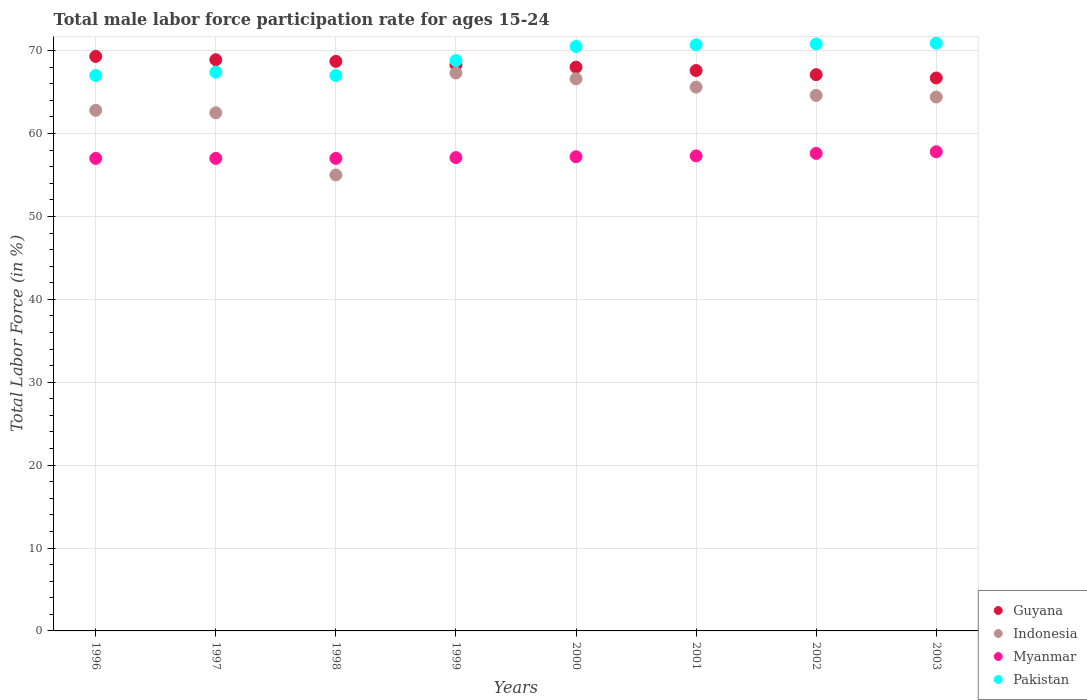How many different coloured dotlines are there?
Offer a very short reply. 4. What is the male labor force participation rate in Pakistan in 1998?
Give a very brief answer. 67. Across all years, what is the maximum male labor force participation rate in Myanmar?
Your answer should be very brief. 57.8. Across all years, what is the minimum male labor force participation rate in Pakistan?
Keep it short and to the point. 67. What is the total male labor force participation rate in Guyana in the graph?
Offer a very short reply. 544.6. What is the difference between the male labor force participation rate in Indonesia in 1998 and that in 1999?
Keep it short and to the point. -12.3. What is the average male labor force participation rate in Pakistan per year?
Ensure brevity in your answer.  69.14. In the year 2002, what is the difference between the male labor force participation rate in Pakistan and male labor force participation rate in Guyana?
Provide a succinct answer. 3.7. What is the ratio of the male labor force participation rate in Pakistan in 2000 to that in 2002?
Provide a short and direct response. 1. Is the difference between the male labor force participation rate in Pakistan in 2000 and 2003 greater than the difference between the male labor force participation rate in Guyana in 2000 and 2003?
Offer a very short reply. No. What is the difference between the highest and the second highest male labor force participation rate in Guyana?
Your response must be concise. 0.4. What is the difference between the highest and the lowest male labor force participation rate in Myanmar?
Make the answer very short. 0.8. Is it the case that in every year, the sum of the male labor force participation rate in Myanmar and male labor force participation rate in Indonesia  is greater than the sum of male labor force participation rate in Guyana and male labor force participation rate in Pakistan?
Ensure brevity in your answer.  No. Does the male labor force participation rate in Indonesia monotonically increase over the years?
Your response must be concise. No. How many dotlines are there?
Keep it short and to the point. 4. How many years are there in the graph?
Your answer should be very brief. 8. What is the difference between two consecutive major ticks on the Y-axis?
Provide a succinct answer. 10. Are the values on the major ticks of Y-axis written in scientific E-notation?
Your answer should be compact. No. Does the graph contain grids?
Give a very brief answer. Yes. What is the title of the graph?
Make the answer very short. Total male labor force participation rate for ages 15-24. What is the label or title of the X-axis?
Provide a succinct answer. Years. What is the Total Labor Force (in %) in Guyana in 1996?
Offer a terse response. 69.3. What is the Total Labor Force (in %) of Indonesia in 1996?
Keep it short and to the point. 62.8. What is the Total Labor Force (in %) of Pakistan in 1996?
Give a very brief answer. 67. What is the Total Labor Force (in %) in Guyana in 1997?
Offer a very short reply. 68.9. What is the Total Labor Force (in %) in Indonesia in 1997?
Make the answer very short. 62.5. What is the Total Labor Force (in %) of Pakistan in 1997?
Give a very brief answer. 67.4. What is the Total Labor Force (in %) of Guyana in 1998?
Ensure brevity in your answer.  68.7. What is the Total Labor Force (in %) in Indonesia in 1998?
Your answer should be compact. 55. What is the Total Labor Force (in %) of Myanmar in 1998?
Keep it short and to the point. 57. What is the Total Labor Force (in %) of Pakistan in 1998?
Ensure brevity in your answer.  67. What is the Total Labor Force (in %) of Guyana in 1999?
Ensure brevity in your answer.  68.3. What is the Total Labor Force (in %) in Indonesia in 1999?
Offer a very short reply. 67.3. What is the Total Labor Force (in %) in Myanmar in 1999?
Provide a succinct answer. 57.1. What is the Total Labor Force (in %) of Pakistan in 1999?
Ensure brevity in your answer.  68.8. What is the Total Labor Force (in %) of Indonesia in 2000?
Your answer should be very brief. 66.6. What is the Total Labor Force (in %) in Myanmar in 2000?
Provide a short and direct response. 57.2. What is the Total Labor Force (in %) of Pakistan in 2000?
Offer a very short reply. 70.5. What is the Total Labor Force (in %) of Guyana in 2001?
Offer a terse response. 67.6. What is the Total Labor Force (in %) in Indonesia in 2001?
Provide a short and direct response. 65.6. What is the Total Labor Force (in %) in Myanmar in 2001?
Offer a terse response. 57.3. What is the Total Labor Force (in %) of Pakistan in 2001?
Offer a terse response. 70.7. What is the Total Labor Force (in %) of Guyana in 2002?
Provide a succinct answer. 67.1. What is the Total Labor Force (in %) in Indonesia in 2002?
Provide a succinct answer. 64.6. What is the Total Labor Force (in %) of Myanmar in 2002?
Provide a succinct answer. 57.6. What is the Total Labor Force (in %) of Pakistan in 2002?
Give a very brief answer. 70.8. What is the Total Labor Force (in %) of Guyana in 2003?
Ensure brevity in your answer.  66.7. What is the Total Labor Force (in %) of Indonesia in 2003?
Your response must be concise. 64.4. What is the Total Labor Force (in %) of Myanmar in 2003?
Give a very brief answer. 57.8. What is the Total Labor Force (in %) in Pakistan in 2003?
Make the answer very short. 70.9. Across all years, what is the maximum Total Labor Force (in %) of Guyana?
Your response must be concise. 69.3. Across all years, what is the maximum Total Labor Force (in %) of Indonesia?
Provide a short and direct response. 67.3. Across all years, what is the maximum Total Labor Force (in %) in Myanmar?
Offer a terse response. 57.8. Across all years, what is the maximum Total Labor Force (in %) of Pakistan?
Your answer should be very brief. 70.9. Across all years, what is the minimum Total Labor Force (in %) in Guyana?
Your response must be concise. 66.7. Across all years, what is the minimum Total Labor Force (in %) of Pakistan?
Ensure brevity in your answer.  67. What is the total Total Labor Force (in %) of Guyana in the graph?
Provide a succinct answer. 544.6. What is the total Total Labor Force (in %) in Indonesia in the graph?
Make the answer very short. 508.8. What is the total Total Labor Force (in %) of Myanmar in the graph?
Your answer should be very brief. 458. What is the total Total Labor Force (in %) in Pakistan in the graph?
Your answer should be very brief. 553.1. What is the difference between the Total Labor Force (in %) of Guyana in 1996 and that in 1997?
Provide a short and direct response. 0.4. What is the difference between the Total Labor Force (in %) in Indonesia in 1996 and that in 1997?
Provide a succinct answer. 0.3. What is the difference between the Total Labor Force (in %) of Myanmar in 1996 and that in 1997?
Keep it short and to the point. 0. What is the difference between the Total Labor Force (in %) of Guyana in 1996 and that in 1998?
Your answer should be very brief. 0.6. What is the difference between the Total Labor Force (in %) in Myanmar in 1996 and that in 1998?
Your response must be concise. 0. What is the difference between the Total Labor Force (in %) in Pakistan in 1996 and that in 1998?
Offer a very short reply. 0. What is the difference between the Total Labor Force (in %) of Indonesia in 1996 and that in 1999?
Give a very brief answer. -4.5. What is the difference between the Total Labor Force (in %) in Guyana in 1996 and that in 2001?
Offer a very short reply. 1.7. What is the difference between the Total Labor Force (in %) in Indonesia in 1996 and that in 2001?
Give a very brief answer. -2.8. What is the difference between the Total Labor Force (in %) in Myanmar in 1996 and that in 2001?
Ensure brevity in your answer.  -0.3. What is the difference between the Total Labor Force (in %) of Guyana in 1996 and that in 2002?
Keep it short and to the point. 2.2. What is the difference between the Total Labor Force (in %) of Indonesia in 1996 and that in 2002?
Offer a terse response. -1.8. What is the difference between the Total Labor Force (in %) in Myanmar in 1996 and that in 2002?
Offer a very short reply. -0.6. What is the difference between the Total Labor Force (in %) in Pakistan in 1996 and that in 2002?
Your answer should be very brief. -3.8. What is the difference between the Total Labor Force (in %) of Guyana in 1996 and that in 2003?
Make the answer very short. 2.6. What is the difference between the Total Labor Force (in %) in Indonesia in 1996 and that in 2003?
Your response must be concise. -1.6. What is the difference between the Total Labor Force (in %) of Myanmar in 1996 and that in 2003?
Offer a terse response. -0.8. What is the difference between the Total Labor Force (in %) of Pakistan in 1996 and that in 2003?
Your answer should be very brief. -3.9. What is the difference between the Total Labor Force (in %) of Indonesia in 1997 and that in 1998?
Offer a terse response. 7.5. What is the difference between the Total Labor Force (in %) of Guyana in 1997 and that in 1999?
Keep it short and to the point. 0.6. What is the difference between the Total Labor Force (in %) in Indonesia in 1997 and that in 1999?
Your response must be concise. -4.8. What is the difference between the Total Labor Force (in %) in Myanmar in 1997 and that in 1999?
Your answer should be compact. -0.1. What is the difference between the Total Labor Force (in %) in Myanmar in 1997 and that in 2000?
Keep it short and to the point. -0.2. What is the difference between the Total Labor Force (in %) of Guyana in 1997 and that in 2001?
Keep it short and to the point. 1.3. What is the difference between the Total Labor Force (in %) in Myanmar in 1997 and that in 2001?
Ensure brevity in your answer.  -0.3. What is the difference between the Total Labor Force (in %) of Indonesia in 1997 and that in 2002?
Give a very brief answer. -2.1. What is the difference between the Total Labor Force (in %) in Myanmar in 1997 and that in 2002?
Offer a terse response. -0.6. What is the difference between the Total Labor Force (in %) in Guyana in 1997 and that in 2003?
Offer a terse response. 2.2. What is the difference between the Total Labor Force (in %) of Indonesia in 1997 and that in 2003?
Your answer should be compact. -1.9. What is the difference between the Total Labor Force (in %) of Guyana in 1998 and that in 1999?
Your answer should be very brief. 0.4. What is the difference between the Total Labor Force (in %) of Indonesia in 1998 and that in 1999?
Provide a short and direct response. -12.3. What is the difference between the Total Labor Force (in %) of Myanmar in 1998 and that in 1999?
Give a very brief answer. -0.1. What is the difference between the Total Labor Force (in %) of Guyana in 1998 and that in 2000?
Offer a very short reply. 0.7. What is the difference between the Total Labor Force (in %) of Indonesia in 1998 and that in 2000?
Provide a short and direct response. -11.6. What is the difference between the Total Labor Force (in %) in Indonesia in 1998 and that in 2001?
Provide a succinct answer. -10.6. What is the difference between the Total Labor Force (in %) in Pakistan in 1998 and that in 2001?
Provide a succinct answer. -3.7. What is the difference between the Total Labor Force (in %) in Myanmar in 1998 and that in 2002?
Provide a short and direct response. -0.6. What is the difference between the Total Labor Force (in %) of Pakistan in 1998 and that in 2002?
Offer a very short reply. -3.8. What is the difference between the Total Labor Force (in %) in Guyana in 1998 and that in 2003?
Provide a short and direct response. 2. What is the difference between the Total Labor Force (in %) in Myanmar in 1998 and that in 2003?
Your answer should be very brief. -0.8. What is the difference between the Total Labor Force (in %) of Indonesia in 1999 and that in 2001?
Provide a short and direct response. 1.7. What is the difference between the Total Labor Force (in %) in Indonesia in 1999 and that in 2002?
Keep it short and to the point. 2.7. What is the difference between the Total Labor Force (in %) in Pakistan in 1999 and that in 2002?
Offer a terse response. -2. What is the difference between the Total Labor Force (in %) in Pakistan in 1999 and that in 2003?
Ensure brevity in your answer.  -2.1. What is the difference between the Total Labor Force (in %) of Guyana in 2000 and that in 2001?
Offer a terse response. 0.4. What is the difference between the Total Labor Force (in %) in Indonesia in 2000 and that in 2002?
Offer a very short reply. 2. What is the difference between the Total Labor Force (in %) in Myanmar in 2000 and that in 2003?
Your answer should be compact. -0.6. What is the difference between the Total Labor Force (in %) in Indonesia in 2001 and that in 2002?
Your response must be concise. 1. What is the difference between the Total Labor Force (in %) of Myanmar in 2001 and that in 2002?
Give a very brief answer. -0.3. What is the difference between the Total Labor Force (in %) of Myanmar in 2001 and that in 2003?
Your answer should be compact. -0.5. What is the difference between the Total Labor Force (in %) in Pakistan in 2001 and that in 2003?
Your response must be concise. -0.2. What is the difference between the Total Labor Force (in %) of Guyana in 2002 and that in 2003?
Your answer should be very brief. 0.4. What is the difference between the Total Labor Force (in %) in Guyana in 1996 and the Total Labor Force (in %) in Indonesia in 1998?
Give a very brief answer. 14.3. What is the difference between the Total Labor Force (in %) in Guyana in 1996 and the Total Labor Force (in %) in Myanmar in 1998?
Offer a terse response. 12.3. What is the difference between the Total Labor Force (in %) in Guyana in 1996 and the Total Labor Force (in %) in Pakistan in 1998?
Your response must be concise. 2.3. What is the difference between the Total Labor Force (in %) in Indonesia in 1996 and the Total Labor Force (in %) in Myanmar in 1998?
Make the answer very short. 5.8. What is the difference between the Total Labor Force (in %) in Indonesia in 1996 and the Total Labor Force (in %) in Pakistan in 1998?
Offer a terse response. -4.2. What is the difference between the Total Labor Force (in %) of Guyana in 1996 and the Total Labor Force (in %) of Indonesia in 1999?
Your response must be concise. 2. What is the difference between the Total Labor Force (in %) of Guyana in 1996 and the Total Labor Force (in %) of Pakistan in 1999?
Offer a terse response. 0.5. What is the difference between the Total Labor Force (in %) of Indonesia in 1996 and the Total Labor Force (in %) of Myanmar in 1999?
Your response must be concise. 5.7. What is the difference between the Total Labor Force (in %) of Indonesia in 1996 and the Total Labor Force (in %) of Pakistan in 1999?
Make the answer very short. -6. What is the difference between the Total Labor Force (in %) of Guyana in 1996 and the Total Labor Force (in %) of Indonesia in 2000?
Offer a very short reply. 2.7. What is the difference between the Total Labor Force (in %) in Guyana in 1996 and the Total Labor Force (in %) in Pakistan in 2000?
Offer a very short reply. -1.2. What is the difference between the Total Labor Force (in %) of Myanmar in 1996 and the Total Labor Force (in %) of Pakistan in 2000?
Your answer should be very brief. -13.5. What is the difference between the Total Labor Force (in %) of Guyana in 1996 and the Total Labor Force (in %) of Myanmar in 2001?
Make the answer very short. 12. What is the difference between the Total Labor Force (in %) of Guyana in 1996 and the Total Labor Force (in %) of Pakistan in 2001?
Your answer should be compact. -1.4. What is the difference between the Total Labor Force (in %) of Myanmar in 1996 and the Total Labor Force (in %) of Pakistan in 2001?
Keep it short and to the point. -13.7. What is the difference between the Total Labor Force (in %) of Guyana in 1996 and the Total Labor Force (in %) of Indonesia in 2002?
Your answer should be very brief. 4.7. What is the difference between the Total Labor Force (in %) in Guyana in 1996 and the Total Labor Force (in %) in Myanmar in 2002?
Your answer should be compact. 11.7. What is the difference between the Total Labor Force (in %) in Myanmar in 1996 and the Total Labor Force (in %) in Pakistan in 2002?
Give a very brief answer. -13.8. What is the difference between the Total Labor Force (in %) in Guyana in 1996 and the Total Labor Force (in %) in Indonesia in 2003?
Provide a short and direct response. 4.9. What is the difference between the Total Labor Force (in %) in Guyana in 1996 and the Total Labor Force (in %) in Pakistan in 2003?
Provide a short and direct response. -1.6. What is the difference between the Total Labor Force (in %) of Indonesia in 1996 and the Total Labor Force (in %) of Myanmar in 2003?
Provide a short and direct response. 5. What is the difference between the Total Labor Force (in %) in Indonesia in 1996 and the Total Labor Force (in %) in Pakistan in 2003?
Give a very brief answer. -8.1. What is the difference between the Total Labor Force (in %) in Myanmar in 1996 and the Total Labor Force (in %) in Pakistan in 2003?
Provide a succinct answer. -13.9. What is the difference between the Total Labor Force (in %) in Guyana in 1997 and the Total Labor Force (in %) in Indonesia in 1998?
Offer a very short reply. 13.9. What is the difference between the Total Labor Force (in %) in Guyana in 1997 and the Total Labor Force (in %) in Pakistan in 1998?
Your response must be concise. 1.9. What is the difference between the Total Labor Force (in %) in Indonesia in 1997 and the Total Labor Force (in %) in Myanmar in 1998?
Offer a very short reply. 5.5. What is the difference between the Total Labor Force (in %) of Indonesia in 1997 and the Total Labor Force (in %) of Pakistan in 1998?
Give a very brief answer. -4.5. What is the difference between the Total Labor Force (in %) of Guyana in 1997 and the Total Labor Force (in %) of Indonesia in 1999?
Your response must be concise. 1.6. What is the difference between the Total Labor Force (in %) of Guyana in 1997 and the Total Labor Force (in %) of Myanmar in 1999?
Offer a very short reply. 11.8. What is the difference between the Total Labor Force (in %) in Guyana in 1997 and the Total Labor Force (in %) in Pakistan in 1999?
Your answer should be very brief. 0.1. What is the difference between the Total Labor Force (in %) in Indonesia in 1997 and the Total Labor Force (in %) in Myanmar in 1999?
Ensure brevity in your answer.  5.4. What is the difference between the Total Labor Force (in %) of Indonesia in 1997 and the Total Labor Force (in %) of Pakistan in 1999?
Give a very brief answer. -6.3. What is the difference between the Total Labor Force (in %) in Myanmar in 1997 and the Total Labor Force (in %) in Pakistan in 1999?
Offer a very short reply. -11.8. What is the difference between the Total Labor Force (in %) in Guyana in 1997 and the Total Labor Force (in %) in Myanmar in 2000?
Give a very brief answer. 11.7. What is the difference between the Total Labor Force (in %) in Indonesia in 1997 and the Total Labor Force (in %) in Myanmar in 2000?
Your answer should be compact. 5.3. What is the difference between the Total Labor Force (in %) in Indonesia in 1997 and the Total Labor Force (in %) in Pakistan in 2000?
Your answer should be compact. -8. What is the difference between the Total Labor Force (in %) in Guyana in 1997 and the Total Labor Force (in %) in Myanmar in 2001?
Ensure brevity in your answer.  11.6. What is the difference between the Total Labor Force (in %) of Indonesia in 1997 and the Total Labor Force (in %) of Pakistan in 2001?
Offer a very short reply. -8.2. What is the difference between the Total Labor Force (in %) of Myanmar in 1997 and the Total Labor Force (in %) of Pakistan in 2001?
Your answer should be compact. -13.7. What is the difference between the Total Labor Force (in %) of Guyana in 1997 and the Total Labor Force (in %) of Indonesia in 2003?
Make the answer very short. 4.5. What is the difference between the Total Labor Force (in %) in Myanmar in 1997 and the Total Labor Force (in %) in Pakistan in 2003?
Offer a very short reply. -13.9. What is the difference between the Total Labor Force (in %) of Guyana in 1998 and the Total Labor Force (in %) of Pakistan in 1999?
Offer a terse response. -0.1. What is the difference between the Total Labor Force (in %) in Indonesia in 1998 and the Total Labor Force (in %) in Myanmar in 1999?
Give a very brief answer. -2.1. What is the difference between the Total Labor Force (in %) in Guyana in 1998 and the Total Labor Force (in %) in Pakistan in 2000?
Provide a short and direct response. -1.8. What is the difference between the Total Labor Force (in %) in Indonesia in 1998 and the Total Labor Force (in %) in Myanmar in 2000?
Provide a succinct answer. -2.2. What is the difference between the Total Labor Force (in %) of Indonesia in 1998 and the Total Labor Force (in %) of Pakistan in 2000?
Offer a terse response. -15.5. What is the difference between the Total Labor Force (in %) in Myanmar in 1998 and the Total Labor Force (in %) in Pakistan in 2000?
Your answer should be compact. -13.5. What is the difference between the Total Labor Force (in %) of Guyana in 1998 and the Total Labor Force (in %) of Pakistan in 2001?
Offer a very short reply. -2. What is the difference between the Total Labor Force (in %) of Indonesia in 1998 and the Total Labor Force (in %) of Pakistan in 2001?
Ensure brevity in your answer.  -15.7. What is the difference between the Total Labor Force (in %) of Myanmar in 1998 and the Total Labor Force (in %) of Pakistan in 2001?
Provide a succinct answer. -13.7. What is the difference between the Total Labor Force (in %) in Guyana in 1998 and the Total Labor Force (in %) in Indonesia in 2002?
Provide a succinct answer. 4.1. What is the difference between the Total Labor Force (in %) in Guyana in 1998 and the Total Labor Force (in %) in Pakistan in 2002?
Your response must be concise. -2.1. What is the difference between the Total Labor Force (in %) of Indonesia in 1998 and the Total Labor Force (in %) of Pakistan in 2002?
Provide a succinct answer. -15.8. What is the difference between the Total Labor Force (in %) in Myanmar in 1998 and the Total Labor Force (in %) in Pakistan in 2002?
Provide a short and direct response. -13.8. What is the difference between the Total Labor Force (in %) in Guyana in 1998 and the Total Labor Force (in %) in Indonesia in 2003?
Offer a terse response. 4.3. What is the difference between the Total Labor Force (in %) of Guyana in 1998 and the Total Labor Force (in %) of Myanmar in 2003?
Ensure brevity in your answer.  10.9. What is the difference between the Total Labor Force (in %) in Guyana in 1998 and the Total Labor Force (in %) in Pakistan in 2003?
Your answer should be compact. -2.2. What is the difference between the Total Labor Force (in %) of Indonesia in 1998 and the Total Labor Force (in %) of Myanmar in 2003?
Give a very brief answer. -2.8. What is the difference between the Total Labor Force (in %) of Indonesia in 1998 and the Total Labor Force (in %) of Pakistan in 2003?
Ensure brevity in your answer.  -15.9. What is the difference between the Total Labor Force (in %) of Myanmar in 1998 and the Total Labor Force (in %) of Pakistan in 2003?
Give a very brief answer. -13.9. What is the difference between the Total Labor Force (in %) of Guyana in 1999 and the Total Labor Force (in %) of Indonesia in 2000?
Ensure brevity in your answer.  1.7. What is the difference between the Total Labor Force (in %) of Guyana in 1999 and the Total Labor Force (in %) of Myanmar in 2000?
Give a very brief answer. 11.1. What is the difference between the Total Labor Force (in %) in Guyana in 1999 and the Total Labor Force (in %) in Pakistan in 2001?
Provide a short and direct response. -2.4. What is the difference between the Total Labor Force (in %) of Guyana in 1999 and the Total Labor Force (in %) of Pakistan in 2002?
Your response must be concise. -2.5. What is the difference between the Total Labor Force (in %) of Indonesia in 1999 and the Total Labor Force (in %) of Pakistan in 2002?
Your answer should be compact. -3.5. What is the difference between the Total Labor Force (in %) of Myanmar in 1999 and the Total Labor Force (in %) of Pakistan in 2002?
Offer a terse response. -13.7. What is the difference between the Total Labor Force (in %) in Guyana in 1999 and the Total Labor Force (in %) in Pakistan in 2003?
Offer a very short reply. -2.6. What is the difference between the Total Labor Force (in %) in Indonesia in 1999 and the Total Labor Force (in %) in Myanmar in 2003?
Make the answer very short. 9.5. What is the difference between the Total Labor Force (in %) of Guyana in 2000 and the Total Labor Force (in %) of Indonesia in 2001?
Keep it short and to the point. 2.4. What is the difference between the Total Labor Force (in %) of Indonesia in 2000 and the Total Labor Force (in %) of Myanmar in 2001?
Keep it short and to the point. 9.3. What is the difference between the Total Labor Force (in %) in Indonesia in 2000 and the Total Labor Force (in %) in Pakistan in 2001?
Offer a very short reply. -4.1. What is the difference between the Total Labor Force (in %) of Guyana in 2000 and the Total Labor Force (in %) of Pakistan in 2002?
Your response must be concise. -2.8. What is the difference between the Total Labor Force (in %) of Indonesia in 2000 and the Total Labor Force (in %) of Myanmar in 2002?
Provide a short and direct response. 9. What is the difference between the Total Labor Force (in %) of Myanmar in 2000 and the Total Labor Force (in %) of Pakistan in 2002?
Keep it short and to the point. -13.6. What is the difference between the Total Labor Force (in %) of Guyana in 2000 and the Total Labor Force (in %) of Pakistan in 2003?
Your answer should be very brief. -2.9. What is the difference between the Total Labor Force (in %) of Myanmar in 2000 and the Total Labor Force (in %) of Pakistan in 2003?
Your response must be concise. -13.7. What is the difference between the Total Labor Force (in %) of Guyana in 2001 and the Total Labor Force (in %) of Pakistan in 2002?
Keep it short and to the point. -3.2. What is the difference between the Total Labor Force (in %) of Indonesia in 2001 and the Total Labor Force (in %) of Myanmar in 2002?
Your answer should be compact. 8. What is the difference between the Total Labor Force (in %) in Indonesia in 2001 and the Total Labor Force (in %) in Pakistan in 2002?
Give a very brief answer. -5.2. What is the difference between the Total Labor Force (in %) of Myanmar in 2001 and the Total Labor Force (in %) of Pakistan in 2002?
Ensure brevity in your answer.  -13.5. What is the difference between the Total Labor Force (in %) in Guyana in 2001 and the Total Labor Force (in %) in Indonesia in 2003?
Offer a terse response. 3.2. What is the difference between the Total Labor Force (in %) in Guyana in 2001 and the Total Labor Force (in %) in Myanmar in 2003?
Your answer should be compact. 9.8. What is the difference between the Total Labor Force (in %) in Guyana in 2002 and the Total Labor Force (in %) in Indonesia in 2003?
Your answer should be very brief. 2.7. What is the difference between the Total Labor Force (in %) in Guyana in 2002 and the Total Labor Force (in %) in Myanmar in 2003?
Provide a succinct answer. 9.3. What is the difference between the Total Labor Force (in %) in Indonesia in 2002 and the Total Labor Force (in %) in Myanmar in 2003?
Give a very brief answer. 6.8. What is the difference between the Total Labor Force (in %) in Indonesia in 2002 and the Total Labor Force (in %) in Pakistan in 2003?
Offer a very short reply. -6.3. What is the average Total Labor Force (in %) in Guyana per year?
Offer a terse response. 68.08. What is the average Total Labor Force (in %) of Indonesia per year?
Offer a very short reply. 63.6. What is the average Total Labor Force (in %) of Myanmar per year?
Your response must be concise. 57.25. What is the average Total Labor Force (in %) in Pakistan per year?
Give a very brief answer. 69.14. In the year 1996, what is the difference between the Total Labor Force (in %) in Guyana and Total Labor Force (in %) in Myanmar?
Your response must be concise. 12.3. In the year 1996, what is the difference between the Total Labor Force (in %) in Indonesia and Total Labor Force (in %) in Myanmar?
Keep it short and to the point. 5.8. In the year 1996, what is the difference between the Total Labor Force (in %) of Indonesia and Total Labor Force (in %) of Pakistan?
Your answer should be compact. -4.2. In the year 1997, what is the difference between the Total Labor Force (in %) of Indonesia and Total Labor Force (in %) of Myanmar?
Offer a terse response. 5.5. In the year 1997, what is the difference between the Total Labor Force (in %) of Indonesia and Total Labor Force (in %) of Pakistan?
Keep it short and to the point. -4.9. In the year 1997, what is the difference between the Total Labor Force (in %) of Myanmar and Total Labor Force (in %) of Pakistan?
Offer a terse response. -10.4. In the year 1998, what is the difference between the Total Labor Force (in %) in Guyana and Total Labor Force (in %) in Indonesia?
Keep it short and to the point. 13.7. In the year 1998, what is the difference between the Total Labor Force (in %) in Guyana and Total Labor Force (in %) in Myanmar?
Make the answer very short. 11.7. In the year 1998, what is the difference between the Total Labor Force (in %) in Myanmar and Total Labor Force (in %) in Pakistan?
Offer a terse response. -10. In the year 1999, what is the difference between the Total Labor Force (in %) of Guyana and Total Labor Force (in %) of Indonesia?
Your answer should be very brief. 1. In the year 1999, what is the difference between the Total Labor Force (in %) of Guyana and Total Labor Force (in %) of Pakistan?
Provide a succinct answer. -0.5. In the year 1999, what is the difference between the Total Labor Force (in %) in Indonesia and Total Labor Force (in %) in Pakistan?
Your response must be concise. -1.5. In the year 2000, what is the difference between the Total Labor Force (in %) of Guyana and Total Labor Force (in %) of Indonesia?
Offer a terse response. 1.4. In the year 2000, what is the difference between the Total Labor Force (in %) of Indonesia and Total Labor Force (in %) of Myanmar?
Give a very brief answer. 9.4. In the year 2000, what is the difference between the Total Labor Force (in %) of Indonesia and Total Labor Force (in %) of Pakistan?
Offer a terse response. -3.9. In the year 2000, what is the difference between the Total Labor Force (in %) of Myanmar and Total Labor Force (in %) of Pakistan?
Provide a short and direct response. -13.3. In the year 2001, what is the difference between the Total Labor Force (in %) in Guyana and Total Labor Force (in %) in Myanmar?
Your answer should be compact. 10.3. In the year 2001, what is the difference between the Total Labor Force (in %) in Guyana and Total Labor Force (in %) in Pakistan?
Offer a terse response. -3.1. In the year 2001, what is the difference between the Total Labor Force (in %) in Indonesia and Total Labor Force (in %) in Myanmar?
Provide a succinct answer. 8.3. In the year 2001, what is the difference between the Total Labor Force (in %) of Myanmar and Total Labor Force (in %) of Pakistan?
Give a very brief answer. -13.4. In the year 2002, what is the difference between the Total Labor Force (in %) in Guyana and Total Labor Force (in %) in Indonesia?
Your response must be concise. 2.5. In the year 2002, what is the difference between the Total Labor Force (in %) in Guyana and Total Labor Force (in %) in Myanmar?
Provide a succinct answer. 9.5. In the year 2002, what is the difference between the Total Labor Force (in %) of Indonesia and Total Labor Force (in %) of Pakistan?
Keep it short and to the point. -6.2. In the year 2002, what is the difference between the Total Labor Force (in %) in Myanmar and Total Labor Force (in %) in Pakistan?
Offer a very short reply. -13.2. In the year 2003, what is the difference between the Total Labor Force (in %) in Guyana and Total Labor Force (in %) in Indonesia?
Your answer should be very brief. 2.3. In the year 2003, what is the difference between the Total Labor Force (in %) of Guyana and Total Labor Force (in %) of Pakistan?
Ensure brevity in your answer.  -4.2. What is the ratio of the Total Labor Force (in %) in Myanmar in 1996 to that in 1997?
Give a very brief answer. 1. What is the ratio of the Total Labor Force (in %) of Guyana in 1996 to that in 1998?
Your response must be concise. 1.01. What is the ratio of the Total Labor Force (in %) in Indonesia in 1996 to that in 1998?
Keep it short and to the point. 1.14. What is the ratio of the Total Labor Force (in %) of Myanmar in 1996 to that in 1998?
Keep it short and to the point. 1. What is the ratio of the Total Labor Force (in %) in Pakistan in 1996 to that in 1998?
Offer a very short reply. 1. What is the ratio of the Total Labor Force (in %) in Guyana in 1996 to that in 1999?
Ensure brevity in your answer.  1.01. What is the ratio of the Total Labor Force (in %) of Indonesia in 1996 to that in 1999?
Provide a succinct answer. 0.93. What is the ratio of the Total Labor Force (in %) in Pakistan in 1996 to that in 1999?
Give a very brief answer. 0.97. What is the ratio of the Total Labor Force (in %) of Guyana in 1996 to that in 2000?
Your answer should be compact. 1.02. What is the ratio of the Total Labor Force (in %) in Indonesia in 1996 to that in 2000?
Provide a short and direct response. 0.94. What is the ratio of the Total Labor Force (in %) in Pakistan in 1996 to that in 2000?
Ensure brevity in your answer.  0.95. What is the ratio of the Total Labor Force (in %) of Guyana in 1996 to that in 2001?
Your response must be concise. 1.03. What is the ratio of the Total Labor Force (in %) of Indonesia in 1996 to that in 2001?
Offer a very short reply. 0.96. What is the ratio of the Total Labor Force (in %) in Myanmar in 1996 to that in 2001?
Your answer should be compact. 0.99. What is the ratio of the Total Labor Force (in %) of Pakistan in 1996 to that in 2001?
Your answer should be very brief. 0.95. What is the ratio of the Total Labor Force (in %) in Guyana in 1996 to that in 2002?
Offer a very short reply. 1.03. What is the ratio of the Total Labor Force (in %) of Indonesia in 1996 to that in 2002?
Your answer should be compact. 0.97. What is the ratio of the Total Labor Force (in %) in Pakistan in 1996 to that in 2002?
Ensure brevity in your answer.  0.95. What is the ratio of the Total Labor Force (in %) in Guyana in 1996 to that in 2003?
Provide a succinct answer. 1.04. What is the ratio of the Total Labor Force (in %) in Indonesia in 1996 to that in 2003?
Ensure brevity in your answer.  0.98. What is the ratio of the Total Labor Force (in %) of Myanmar in 1996 to that in 2003?
Make the answer very short. 0.99. What is the ratio of the Total Labor Force (in %) in Pakistan in 1996 to that in 2003?
Provide a short and direct response. 0.94. What is the ratio of the Total Labor Force (in %) in Guyana in 1997 to that in 1998?
Your answer should be very brief. 1. What is the ratio of the Total Labor Force (in %) in Indonesia in 1997 to that in 1998?
Make the answer very short. 1.14. What is the ratio of the Total Labor Force (in %) in Pakistan in 1997 to that in 1998?
Provide a short and direct response. 1.01. What is the ratio of the Total Labor Force (in %) in Guyana in 1997 to that in 1999?
Provide a succinct answer. 1.01. What is the ratio of the Total Labor Force (in %) in Indonesia in 1997 to that in 1999?
Offer a very short reply. 0.93. What is the ratio of the Total Labor Force (in %) of Myanmar in 1997 to that in 1999?
Provide a succinct answer. 1. What is the ratio of the Total Labor Force (in %) of Pakistan in 1997 to that in 1999?
Offer a terse response. 0.98. What is the ratio of the Total Labor Force (in %) of Guyana in 1997 to that in 2000?
Offer a very short reply. 1.01. What is the ratio of the Total Labor Force (in %) of Indonesia in 1997 to that in 2000?
Your answer should be very brief. 0.94. What is the ratio of the Total Labor Force (in %) in Myanmar in 1997 to that in 2000?
Your answer should be very brief. 1. What is the ratio of the Total Labor Force (in %) of Pakistan in 1997 to that in 2000?
Keep it short and to the point. 0.96. What is the ratio of the Total Labor Force (in %) of Guyana in 1997 to that in 2001?
Provide a short and direct response. 1.02. What is the ratio of the Total Labor Force (in %) in Indonesia in 1997 to that in 2001?
Your answer should be very brief. 0.95. What is the ratio of the Total Labor Force (in %) in Pakistan in 1997 to that in 2001?
Give a very brief answer. 0.95. What is the ratio of the Total Labor Force (in %) of Guyana in 1997 to that in 2002?
Give a very brief answer. 1.03. What is the ratio of the Total Labor Force (in %) of Indonesia in 1997 to that in 2002?
Your answer should be very brief. 0.97. What is the ratio of the Total Labor Force (in %) in Pakistan in 1997 to that in 2002?
Make the answer very short. 0.95. What is the ratio of the Total Labor Force (in %) in Guyana in 1997 to that in 2003?
Give a very brief answer. 1.03. What is the ratio of the Total Labor Force (in %) of Indonesia in 1997 to that in 2003?
Offer a terse response. 0.97. What is the ratio of the Total Labor Force (in %) in Myanmar in 1997 to that in 2003?
Give a very brief answer. 0.99. What is the ratio of the Total Labor Force (in %) in Pakistan in 1997 to that in 2003?
Keep it short and to the point. 0.95. What is the ratio of the Total Labor Force (in %) in Guyana in 1998 to that in 1999?
Your answer should be compact. 1.01. What is the ratio of the Total Labor Force (in %) of Indonesia in 1998 to that in 1999?
Give a very brief answer. 0.82. What is the ratio of the Total Labor Force (in %) in Myanmar in 1998 to that in 1999?
Provide a succinct answer. 1. What is the ratio of the Total Labor Force (in %) of Pakistan in 1998 to that in 1999?
Make the answer very short. 0.97. What is the ratio of the Total Labor Force (in %) in Guyana in 1998 to that in 2000?
Give a very brief answer. 1.01. What is the ratio of the Total Labor Force (in %) of Indonesia in 1998 to that in 2000?
Offer a very short reply. 0.83. What is the ratio of the Total Labor Force (in %) of Pakistan in 1998 to that in 2000?
Give a very brief answer. 0.95. What is the ratio of the Total Labor Force (in %) in Guyana in 1998 to that in 2001?
Provide a short and direct response. 1.02. What is the ratio of the Total Labor Force (in %) in Indonesia in 1998 to that in 2001?
Give a very brief answer. 0.84. What is the ratio of the Total Labor Force (in %) in Myanmar in 1998 to that in 2001?
Keep it short and to the point. 0.99. What is the ratio of the Total Labor Force (in %) in Pakistan in 1998 to that in 2001?
Make the answer very short. 0.95. What is the ratio of the Total Labor Force (in %) in Guyana in 1998 to that in 2002?
Ensure brevity in your answer.  1.02. What is the ratio of the Total Labor Force (in %) of Indonesia in 1998 to that in 2002?
Your response must be concise. 0.85. What is the ratio of the Total Labor Force (in %) in Myanmar in 1998 to that in 2002?
Keep it short and to the point. 0.99. What is the ratio of the Total Labor Force (in %) of Pakistan in 1998 to that in 2002?
Ensure brevity in your answer.  0.95. What is the ratio of the Total Labor Force (in %) in Indonesia in 1998 to that in 2003?
Your response must be concise. 0.85. What is the ratio of the Total Labor Force (in %) of Myanmar in 1998 to that in 2003?
Offer a very short reply. 0.99. What is the ratio of the Total Labor Force (in %) of Pakistan in 1998 to that in 2003?
Provide a succinct answer. 0.94. What is the ratio of the Total Labor Force (in %) in Guyana in 1999 to that in 2000?
Provide a short and direct response. 1. What is the ratio of the Total Labor Force (in %) in Indonesia in 1999 to that in 2000?
Your answer should be very brief. 1.01. What is the ratio of the Total Labor Force (in %) in Myanmar in 1999 to that in 2000?
Make the answer very short. 1. What is the ratio of the Total Labor Force (in %) in Pakistan in 1999 to that in 2000?
Your answer should be very brief. 0.98. What is the ratio of the Total Labor Force (in %) of Guyana in 1999 to that in 2001?
Offer a terse response. 1.01. What is the ratio of the Total Labor Force (in %) in Indonesia in 1999 to that in 2001?
Keep it short and to the point. 1.03. What is the ratio of the Total Labor Force (in %) in Myanmar in 1999 to that in 2001?
Your answer should be compact. 1. What is the ratio of the Total Labor Force (in %) of Pakistan in 1999 to that in 2001?
Provide a short and direct response. 0.97. What is the ratio of the Total Labor Force (in %) in Guyana in 1999 to that in 2002?
Your answer should be compact. 1.02. What is the ratio of the Total Labor Force (in %) in Indonesia in 1999 to that in 2002?
Provide a succinct answer. 1.04. What is the ratio of the Total Labor Force (in %) of Pakistan in 1999 to that in 2002?
Provide a succinct answer. 0.97. What is the ratio of the Total Labor Force (in %) of Indonesia in 1999 to that in 2003?
Your response must be concise. 1.04. What is the ratio of the Total Labor Force (in %) of Myanmar in 1999 to that in 2003?
Ensure brevity in your answer.  0.99. What is the ratio of the Total Labor Force (in %) of Pakistan in 1999 to that in 2003?
Provide a short and direct response. 0.97. What is the ratio of the Total Labor Force (in %) of Guyana in 2000 to that in 2001?
Ensure brevity in your answer.  1.01. What is the ratio of the Total Labor Force (in %) in Indonesia in 2000 to that in 2001?
Offer a very short reply. 1.02. What is the ratio of the Total Labor Force (in %) in Guyana in 2000 to that in 2002?
Provide a short and direct response. 1.01. What is the ratio of the Total Labor Force (in %) of Indonesia in 2000 to that in 2002?
Provide a short and direct response. 1.03. What is the ratio of the Total Labor Force (in %) in Myanmar in 2000 to that in 2002?
Your answer should be compact. 0.99. What is the ratio of the Total Labor Force (in %) in Guyana in 2000 to that in 2003?
Ensure brevity in your answer.  1.02. What is the ratio of the Total Labor Force (in %) in Indonesia in 2000 to that in 2003?
Your answer should be very brief. 1.03. What is the ratio of the Total Labor Force (in %) in Pakistan in 2000 to that in 2003?
Give a very brief answer. 0.99. What is the ratio of the Total Labor Force (in %) in Guyana in 2001 to that in 2002?
Keep it short and to the point. 1.01. What is the ratio of the Total Labor Force (in %) in Indonesia in 2001 to that in 2002?
Make the answer very short. 1.02. What is the ratio of the Total Labor Force (in %) of Guyana in 2001 to that in 2003?
Offer a very short reply. 1.01. What is the ratio of the Total Labor Force (in %) of Indonesia in 2001 to that in 2003?
Your answer should be very brief. 1.02. What is the ratio of the Total Labor Force (in %) in Myanmar in 2001 to that in 2003?
Your response must be concise. 0.99. What is the ratio of the Total Labor Force (in %) of Pakistan in 2001 to that in 2003?
Offer a terse response. 1. What is the ratio of the Total Labor Force (in %) of Pakistan in 2002 to that in 2003?
Provide a succinct answer. 1. What is the difference between the highest and the second highest Total Labor Force (in %) of Indonesia?
Provide a succinct answer. 0.7. What is the difference between the highest and the lowest Total Labor Force (in %) of Guyana?
Offer a terse response. 2.6. 